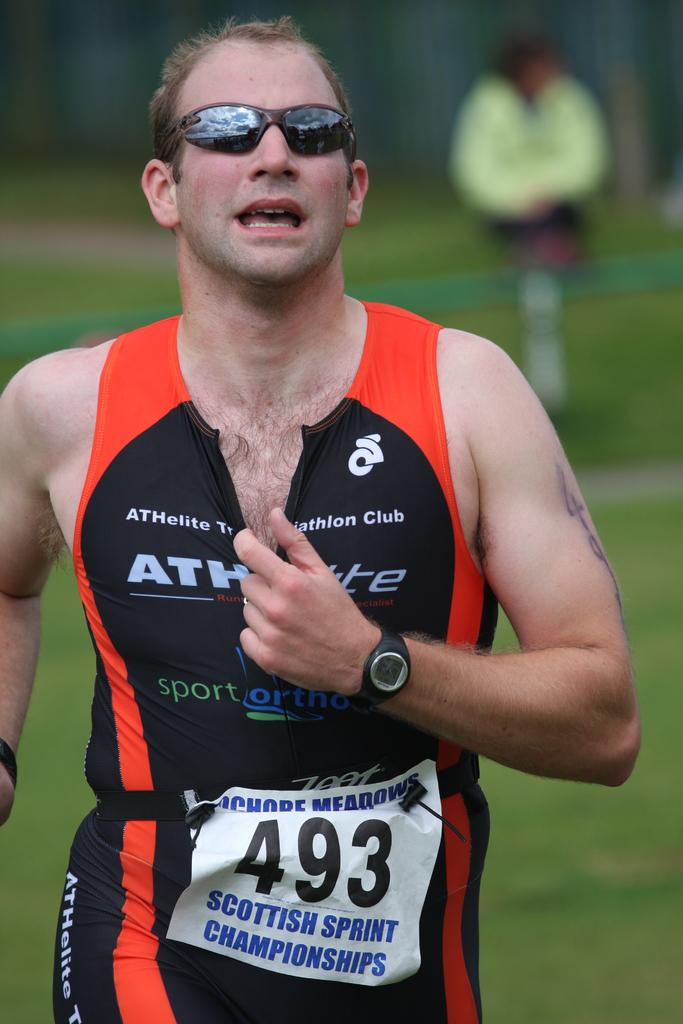Provide a one-sentence caption for the provided image. A runner in the Scottish Sprint Championships moves along a grassy area. 